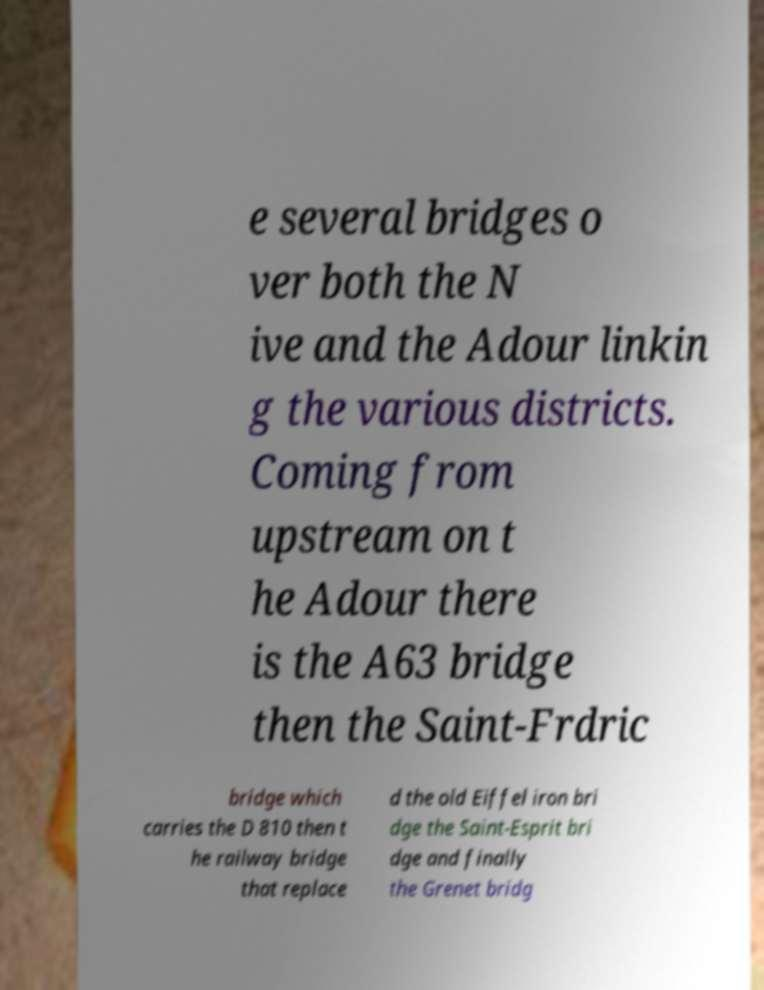I need the written content from this picture converted into text. Can you do that? e several bridges o ver both the N ive and the Adour linkin g the various districts. Coming from upstream on t he Adour there is the A63 bridge then the Saint-Frdric bridge which carries the D 810 then t he railway bridge that replace d the old Eiffel iron bri dge the Saint-Esprit bri dge and finally the Grenet bridg 